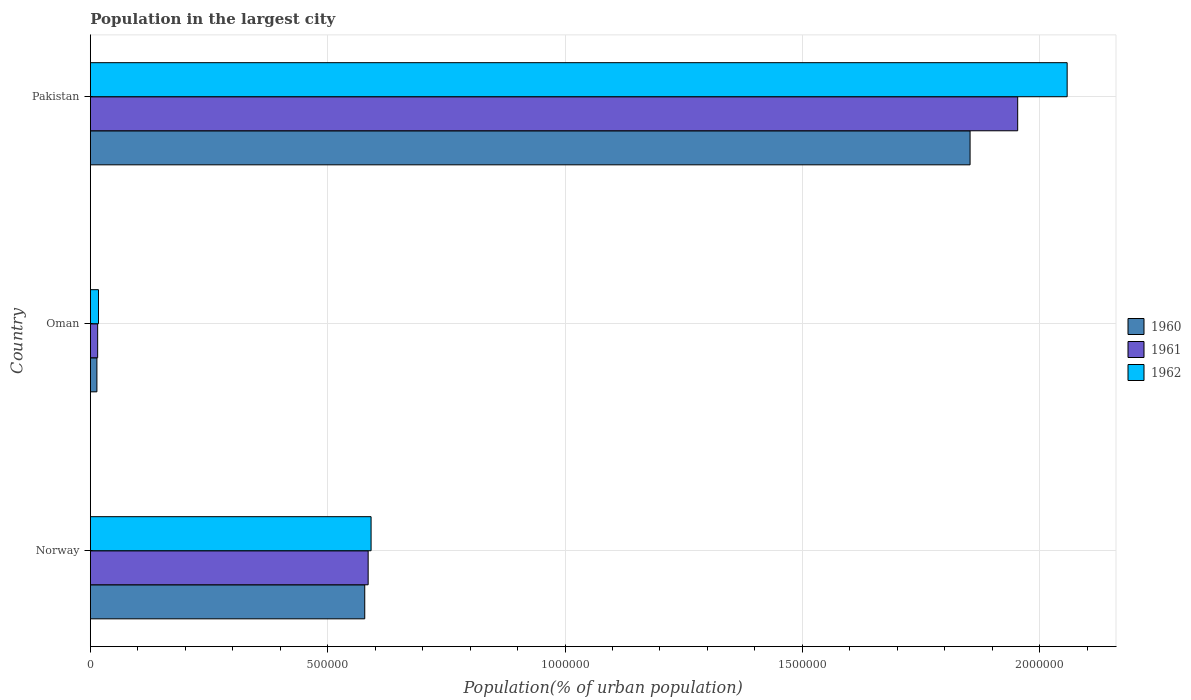How many different coloured bars are there?
Provide a short and direct response. 3. Are the number of bars per tick equal to the number of legend labels?
Your answer should be very brief. Yes. Are the number of bars on each tick of the Y-axis equal?
Provide a succinct answer. Yes. How many bars are there on the 1st tick from the bottom?
Ensure brevity in your answer.  3. What is the population in the largest city in 1960 in Norway?
Keep it short and to the point. 5.78e+05. Across all countries, what is the maximum population in the largest city in 1961?
Ensure brevity in your answer.  1.95e+06. Across all countries, what is the minimum population in the largest city in 1961?
Make the answer very short. 1.54e+04. In which country was the population in the largest city in 1960 minimum?
Make the answer very short. Oman. What is the total population in the largest city in 1960 in the graph?
Provide a succinct answer. 2.45e+06. What is the difference between the population in the largest city in 1961 in Norway and that in Oman?
Provide a short and direct response. 5.70e+05. What is the difference between the population in the largest city in 1961 in Pakistan and the population in the largest city in 1960 in Norway?
Your answer should be very brief. 1.38e+06. What is the average population in the largest city in 1960 per country?
Provide a succinct answer. 8.15e+05. What is the difference between the population in the largest city in 1962 and population in the largest city in 1960 in Oman?
Keep it short and to the point. 3326. What is the ratio of the population in the largest city in 1961 in Norway to that in Oman?
Keep it short and to the point. 38.09. Is the population in the largest city in 1962 in Norway less than that in Oman?
Make the answer very short. No. Is the difference between the population in the largest city in 1962 in Oman and Pakistan greater than the difference between the population in the largest city in 1960 in Oman and Pakistan?
Provide a succinct answer. No. What is the difference between the highest and the second highest population in the largest city in 1961?
Your response must be concise. 1.37e+06. What is the difference between the highest and the lowest population in the largest city in 1960?
Give a very brief answer. 1.84e+06. How many bars are there?
Provide a short and direct response. 9. How many countries are there in the graph?
Give a very brief answer. 3. What is the difference between two consecutive major ticks on the X-axis?
Your response must be concise. 5.00e+05. Are the values on the major ticks of X-axis written in scientific E-notation?
Your answer should be very brief. No. Does the graph contain any zero values?
Offer a terse response. No. Does the graph contain grids?
Your answer should be compact. Yes. Where does the legend appear in the graph?
Your answer should be very brief. Center right. How many legend labels are there?
Your answer should be very brief. 3. What is the title of the graph?
Make the answer very short. Population in the largest city. What is the label or title of the X-axis?
Make the answer very short. Population(% of urban population). What is the label or title of the Y-axis?
Provide a short and direct response. Country. What is the Population(% of urban population) in 1960 in Norway?
Provide a short and direct response. 5.78e+05. What is the Population(% of urban population) of 1961 in Norway?
Offer a very short reply. 5.85e+05. What is the Population(% of urban population) of 1962 in Norway?
Your answer should be compact. 5.91e+05. What is the Population(% of urban population) of 1960 in Oman?
Your answer should be very brief. 1.38e+04. What is the Population(% of urban population) of 1961 in Oman?
Offer a very short reply. 1.54e+04. What is the Population(% of urban population) in 1962 in Oman?
Offer a very short reply. 1.71e+04. What is the Population(% of urban population) of 1960 in Pakistan?
Keep it short and to the point. 1.85e+06. What is the Population(% of urban population) of 1961 in Pakistan?
Make the answer very short. 1.95e+06. What is the Population(% of urban population) of 1962 in Pakistan?
Your answer should be very brief. 2.06e+06. Across all countries, what is the maximum Population(% of urban population) in 1960?
Provide a short and direct response. 1.85e+06. Across all countries, what is the maximum Population(% of urban population) in 1961?
Offer a terse response. 1.95e+06. Across all countries, what is the maximum Population(% of urban population) of 1962?
Your response must be concise. 2.06e+06. Across all countries, what is the minimum Population(% of urban population) in 1960?
Offer a terse response. 1.38e+04. Across all countries, what is the minimum Population(% of urban population) of 1961?
Offer a very short reply. 1.54e+04. Across all countries, what is the minimum Population(% of urban population) of 1962?
Ensure brevity in your answer.  1.71e+04. What is the total Population(% of urban population) in 1960 in the graph?
Your response must be concise. 2.45e+06. What is the total Population(% of urban population) of 1961 in the graph?
Give a very brief answer. 2.55e+06. What is the total Population(% of urban population) of 1962 in the graph?
Provide a short and direct response. 2.67e+06. What is the difference between the Population(% of urban population) in 1960 in Norway and that in Oman?
Offer a terse response. 5.64e+05. What is the difference between the Population(% of urban population) of 1961 in Norway and that in Oman?
Offer a very short reply. 5.70e+05. What is the difference between the Population(% of urban population) of 1962 in Norway and that in Oman?
Provide a succinct answer. 5.74e+05. What is the difference between the Population(% of urban population) of 1960 in Norway and that in Pakistan?
Your answer should be very brief. -1.28e+06. What is the difference between the Population(% of urban population) of 1961 in Norway and that in Pakistan?
Offer a very short reply. -1.37e+06. What is the difference between the Population(% of urban population) in 1962 in Norway and that in Pakistan?
Give a very brief answer. -1.47e+06. What is the difference between the Population(% of urban population) in 1960 in Oman and that in Pakistan?
Your answer should be compact. -1.84e+06. What is the difference between the Population(% of urban population) in 1961 in Oman and that in Pakistan?
Provide a short and direct response. -1.94e+06. What is the difference between the Population(% of urban population) in 1962 in Oman and that in Pakistan?
Provide a succinct answer. -2.04e+06. What is the difference between the Population(% of urban population) in 1960 in Norway and the Population(% of urban population) in 1961 in Oman?
Keep it short and to the point. 5.63e+05. What is the difference between the Population(% of urban population) in 1960 in Norway and the Population(% of urban population) in 1962 in Oman?
Provide a succinct answer. 5.61e+05. What is the difference between the Population(% of urban population) of 1961 in Norway and the Population(% of urban population) of 1962 in Oman?
Ensure brevity in your answer.  5.68e+05. What is the difference between the Population(% of urban population) of 1960 in Norway and the Population(% of urban population) of 1961 in Pakistan?
Provide a succinct answer. -1.38e+06. What is the difference between the Population(% of urban population) of 1960 in Norway and the Population(% of urban population) of 1962 in Pakistan?
Provide a short and direct response. -1.48e+06. What is the difference between the Population(% of urban population) in 1961 in Norway and the Population(% of urban population) in 1962 in Pakistan?
Provide a succinct answer. -1.47e+06. What is the difference between the Population(% of urban population) of 1960 in Oman and the Population(% of urban population) of 1961 in Pakistan?
Provide a short and direct response. -1.94e+06. What is the difference between the Population(% of urban population) in 1960 in Oman and the Population(% of urban population) in 1962 in Pakistan?
Give a very brief answer. -2.04e+06. What is the difference between the Population(% of urban population) of 1961 in Oman and the Population(% of urban population) of 1962 in Pakistan?
Your response must be concise. -2.04e+06. What is the average Population(% of urban population) in 1960 per country?
Your response must be concise. 8.15e+05. What is the average Population(% of urban population) in 1961 per country?
Provide a succinct answer. 8.51e+05. What is the average Population(% of urban population) in 1962 per country?
Your answer should be very brief. 8.89e+05. What is the difference between the Population(% of urban population) of 1960 and Population(% of urban population) of 1961 in Norway?
Your answer should be very brief. -7186. What is the difference between the Population(% of urban population) of 1960 and Population(% of urban population) of 1962 in Norway?
Give a very brief answer. -1.34e+04. What is the difference between the Population(% of urban population) in 1961 and Population(% of urban population) in 1962 in Norway?
Your response must be concise. -6168. What is the difference between the Population(% of urban population) of 1960 and Population(% of urban population) of 1961 in Oman?
Your response must be concise. -1572. What is the difference between the Population(% of urban population) in 1960 and Population(% of urban population) in 1962 in Oman?
Provide a short and direct response. -3326. What is the difference between the Population(% of urban population) of 1961 and Population(% of urban population) of 1962 in Oman?
Provide a short and direct response. -1754. What is the difference between the Population(% of urban population) in 1960 and Population(% of urban population) in 1961 in Pakistan?
Make the answer very short. -1.00e+05. What is the difference between the Population(% of urban population) in 1960 and Population(% of urban population) in 1962 in Pakistan?
Ensure brevity in your answer.  -2.05e+05. What is the difference between the Population(% of urban population) of 1961 and Population(% of urban population) of 1962 in Pakistan?
Your answer should be very brief. -1.04e+05. What is the ratio of the Population(% of urban population) of 1960 in Norway to that in Oman?
Your response must be concise. 41.91. What is the ratio of the Population(% of urban population) in 1961 in Norway to that in Oman?
Offer a terse response. 38.09. What is the ratio of the Population(% of urban population) of 1962 in Norway to that in Oman?
Give a very brief answer. 34.55. What is the ratio of the Population(% of urban population) in 1960 in Norway to that in Pakistan?
Provide a succinct answer. 0.31. What is the ratio of the Population(% of urban population) of 1961 in Norway to that in Pakistan?
Ensure brevity in your answer.  0.3. What is the ratio of the Population(% of urban population) of 1962 in Norway to that in Pakistan?
Give a very brief answer. 0.29. What is the ratio of the Population(% of urban population) in 1960 in Oman to that in Pakistan?
Provide a succinct answer. 0.01. What is the ratio of the Population(% of urban population) in 1961 in Oman to that in Pakistan?
Give a very brief answer. 0.01. What is the ratio of the Population(% of urban population) in 1962 in Oman to that in Pakistan?
Provide a short and direct response. 0.01. What is the difference between the highest and the second highest Population(% of urban population) of 1960?
Your response must be concise. 1.28e+06. What is the difference between the highest and the second highest Population(% of urban population) of 1961?
Provide a succinct answer. 1.37e+06. What is the difference between the highest and the second highest Population(% of urban population) of 1962?
Your answer should be very brief. 1.47e+06. What is the difference between the highest and the lowest Population(% of urban population) of 1960?
Offer a terse response. 1.84e+06. What is the difference between the highest and the lowest Population(% of urban population) of 1961?
Provide a succinct answer. 1.94e+06. What is the difference between the highest and the lowest Population(% of urban population) in 1962?
Keep it short and to the point. 2.04e+06. 